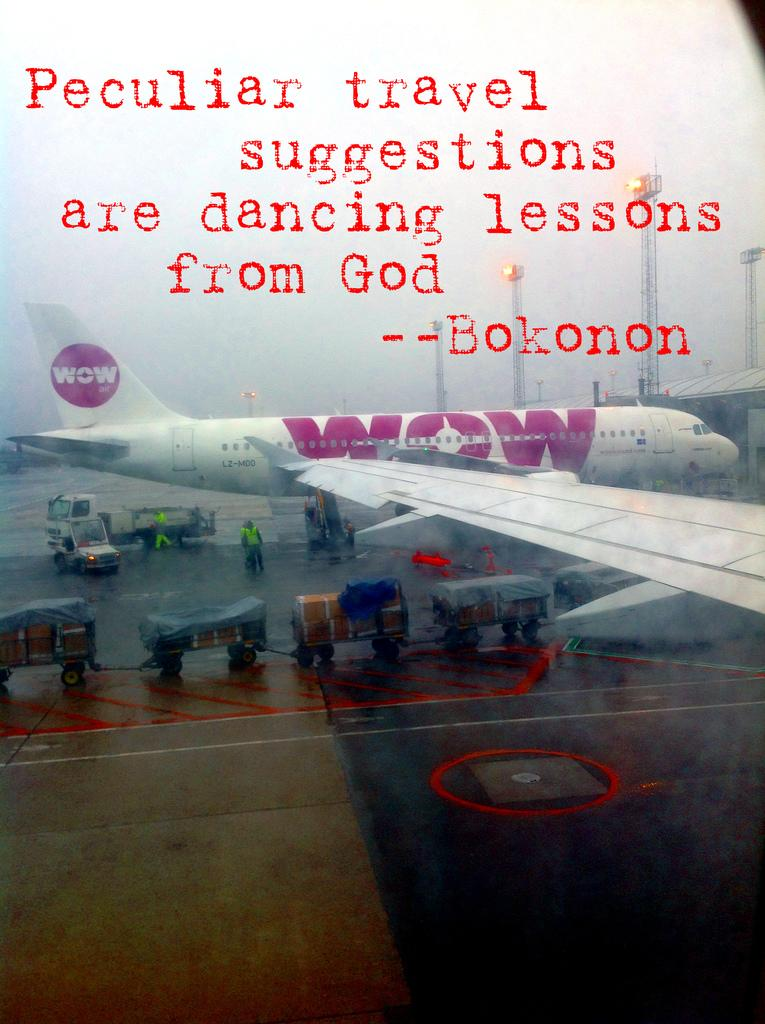<image>
Write a terse but informative summary of the picture. An airplane has WOW in purple and white on it's tail and side. 